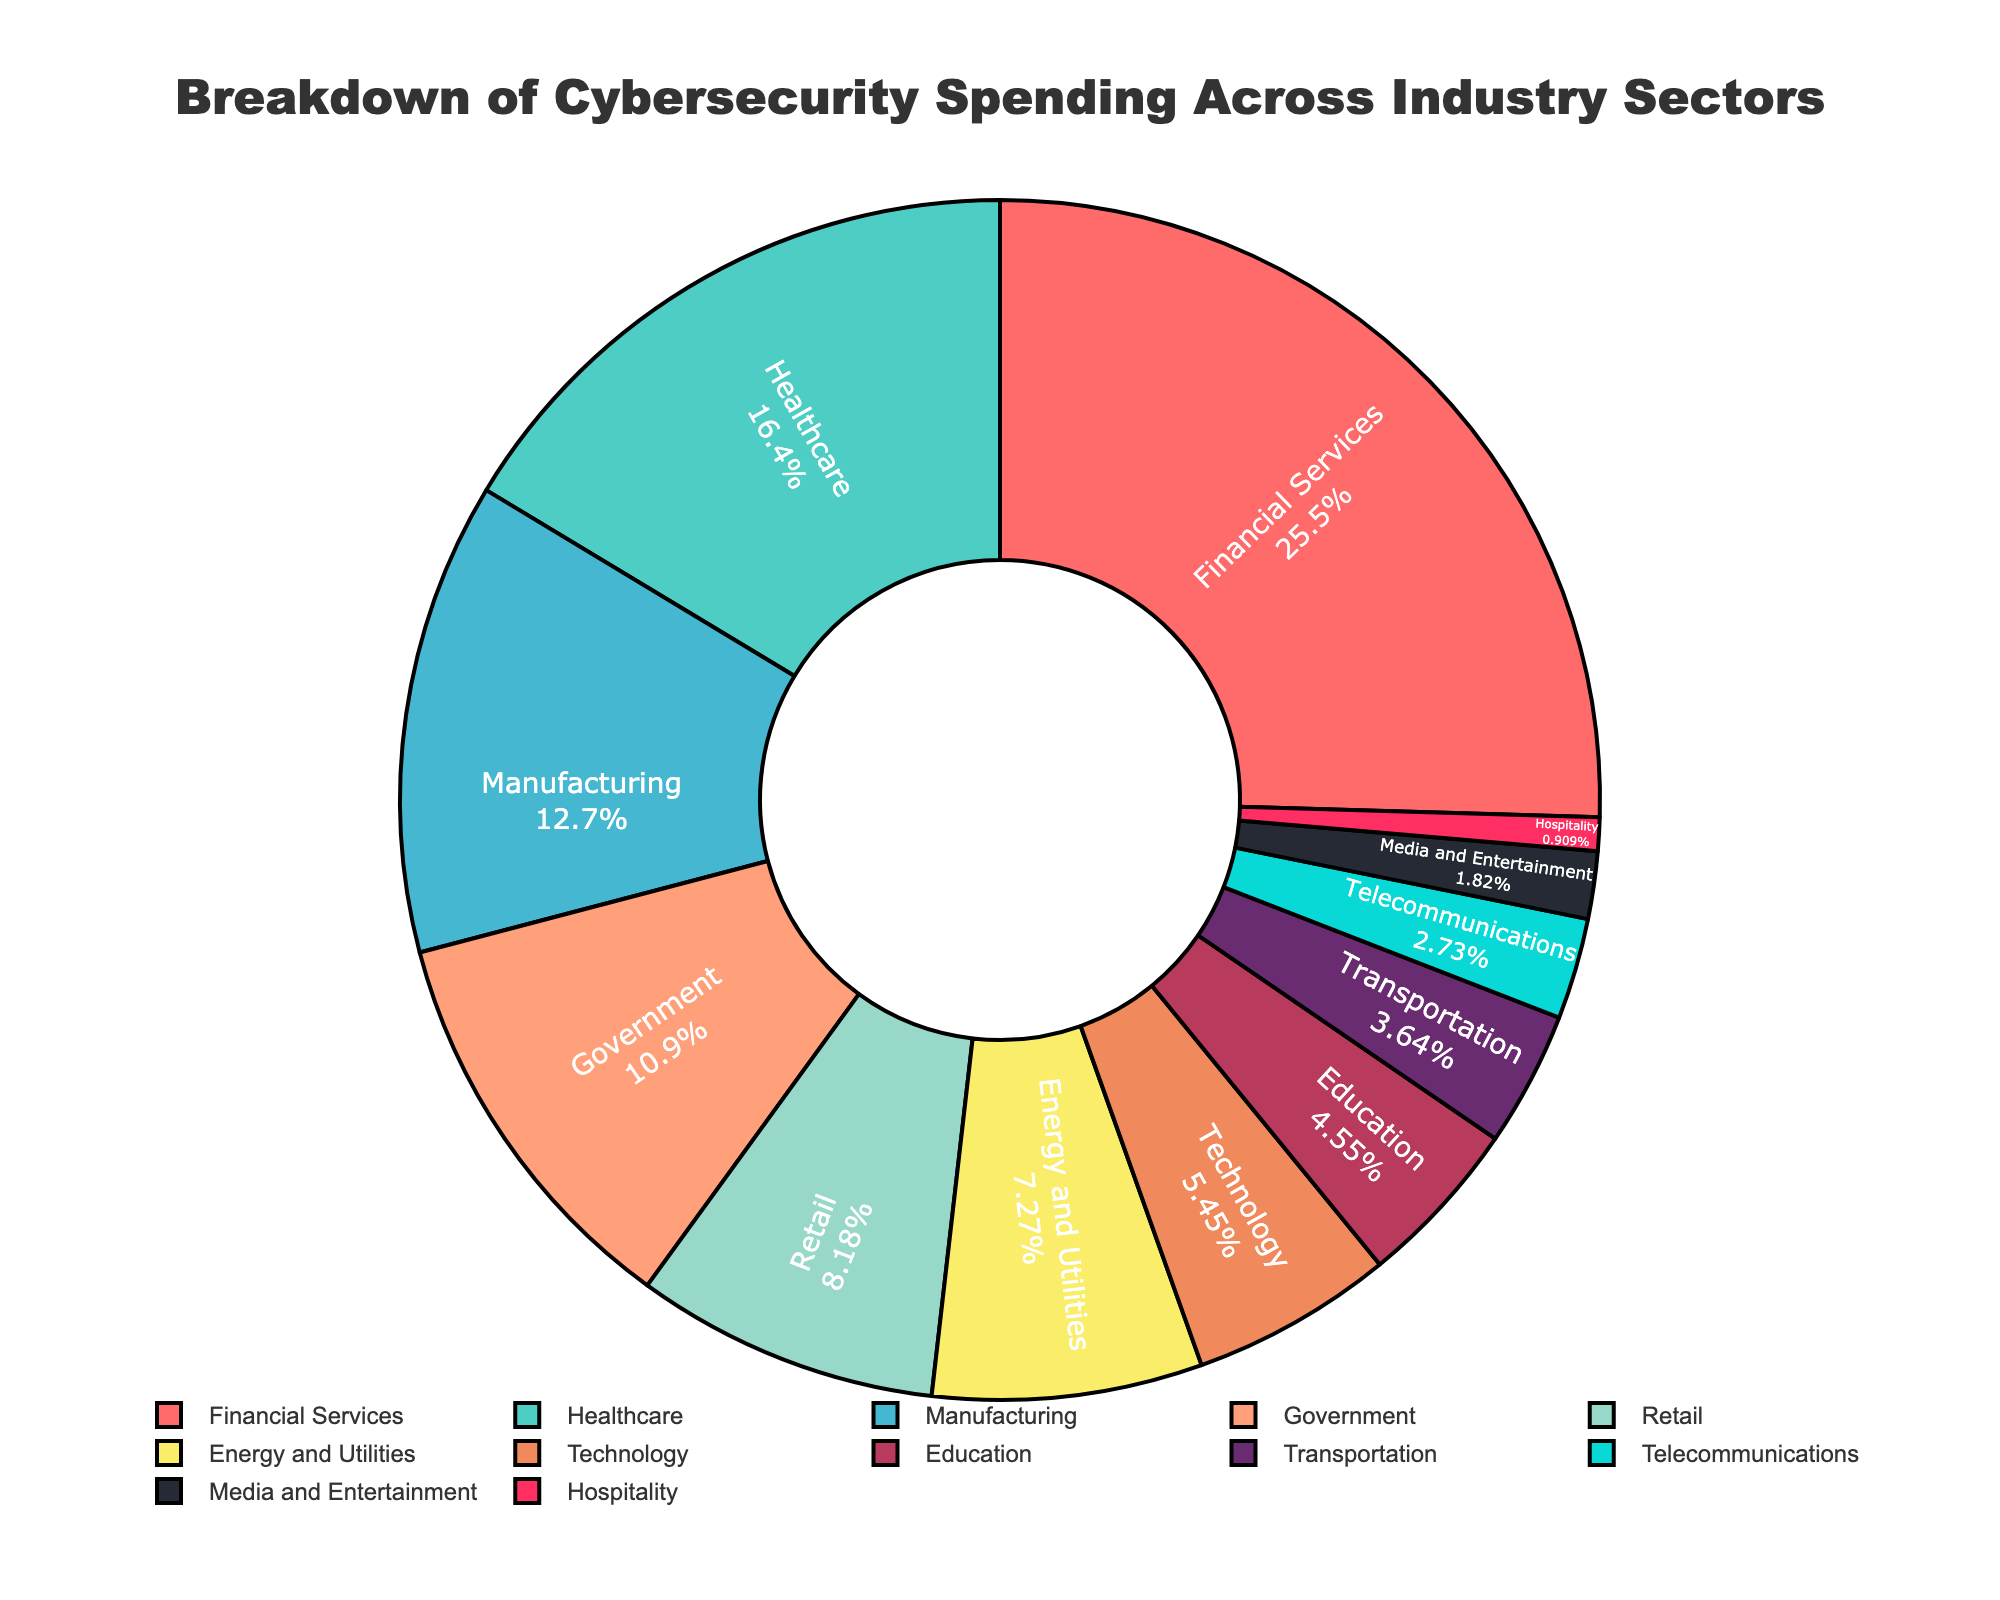What industry sector has the highest percentage of cybersecurity spending? From the figure, the sector with the largest segment is the Financial Services sector.
Answer: Financial Services What is the combined percentage of cybersecurity spending for the Healthcare and Government sectors? The Healthcare sector has 18% and the Government sector has 12%, so their combined percentage is 18% + 12% = 30%.
Answer: 30% Which industry sector spends more on cybersecurity: Manufacturing or Retail? The Manufacturing sector has a 14% share, while the Retail sector has a 9% share. Therefore, Manufacturing spends more than Retail.
Answer: Manufacturing How does the percentage of cybersecurity spending for the Education sector compare to the Telecommunications sector? The Education sector has a 5% share, whereas the Telecommunications sector has a 3% share, making Education spend more.
Answer: Education What sector has the smallest share in cybersecurity spending, and what is its percentage? The sector with the smallest segment in the pie chart is the Hospitality sector, which has a 1% share.
Answer: Hospitality What is the difference in cybersecurity spending between the Energy and Utilities sector and the Media and Entertainment sector? The Energy and Utilities sector has an 8% share, while the Media and Entertainment sector has a 2% share. The difference is 8% - 2% = 6%.
Answer: 6% If the percentage of cybersecurity spending for the Technology sector doubles, what will it be? The Technology sector currently has a 6% share. If it doubles, it will be 6% * 2 = 12%.
Answer: 12% Which sectors have a cybersecurity spending percentage greater than 10%? From the chart, the sectors with percentages greater than 10% are Financial Services (28%), Healthcare (18%), Manufacturing (14%), and Government (12%).
Answer: Financial Services, Healthcare, Manufacturing, Government Order the sectors with a cybersecurity spending percentage below 10% from highest to lowest. The sectors below 10% are Retail (9%), Energy and Utilities (8%), Technology (6%), Education (5%), Transportation (4%), Telecommunications (3%), Media and Entertainment (2%), and Hospitality (1%).
Answer: Retail, Energy and Utilities, Technology, Education, Transportation, Telecommunications, Media and Entertainment, Hospitality How much more does the Financial Services sector spend on cybersecurity compared to the Transportation sector, in percentage terms? Financial Services has a 28% share, and Transportation has a 4% share. The difference is 28% - 4% = 24%.
Answer: 24% 